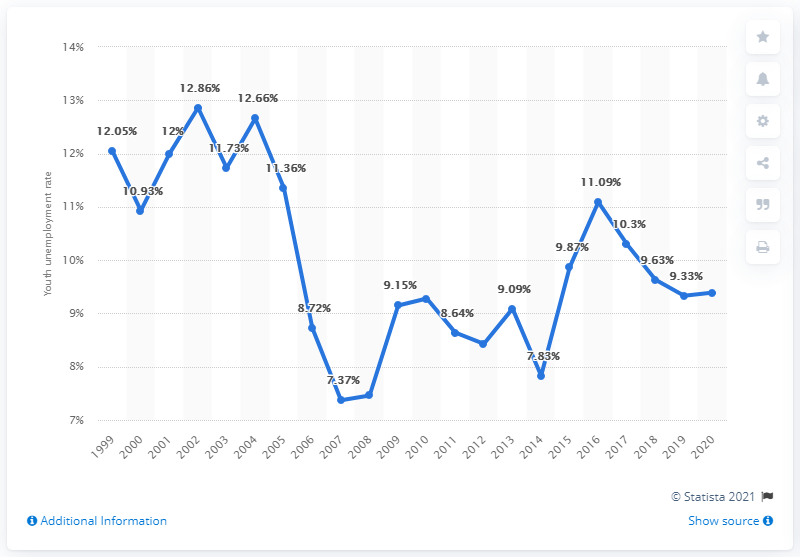Identify some key points in this picture. According to data from 2020, the youth unemployment rate in Norway was 9.39%. 